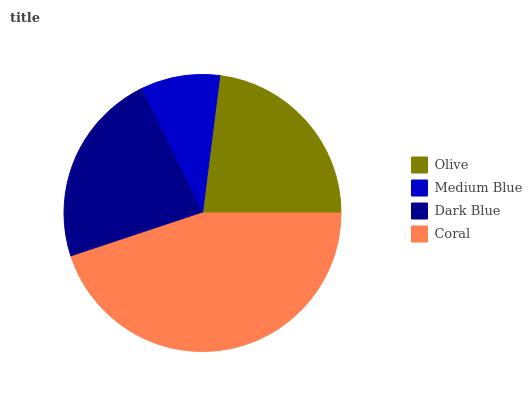Is Medium Blue the minimum?
Answer yes or no. Yes. Is Coral the maximum?
Answer yes or no. Yes. Is Dark Blue the minimum?
Answer yes or no. No. Is Dark Blue the maximum?
Answer yes or no. No. Is Dark Blue greater than Medium Blue?
Answer yes or no. Yes. Is Medium Blue less than Dark Blue?
Answer yes or no. Yes. Is Medium Blue greater than Dark Blue?
Answer yes or no. No. Is Dark Blue less than Medium Blue?
Answer yes or no. No. Is Olive the high median?
Answer yes or no. Yes. Is Dark Blue the low median?
Answer yes or no. Yes. Is Coral the high median?
Answer yes or no. No. Is Medium Blue the low median?
Answer yes or no. No. 